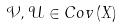<formula> <loc_0><loc_0><loc_500><loc_500>\mathcal { V } , \mathcal { U } \in C o v \left ( X \right )</formula> 